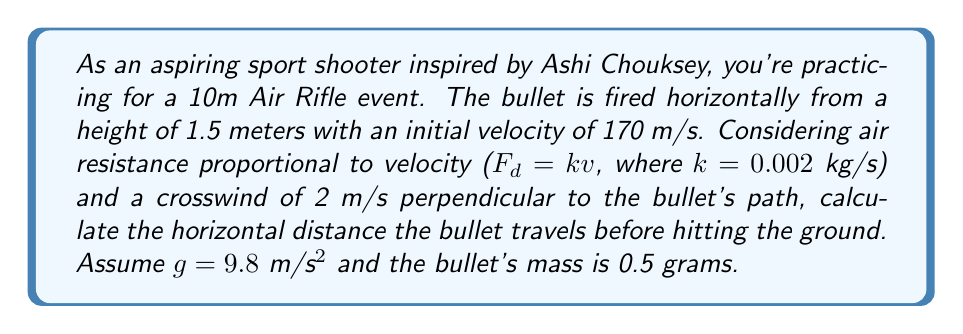Teach me how to tackle this problem. To solve this problem, we need to consider the motion in three dimensions: horizontal (x), vertical (y), and lateral (z) due to wind. Let's break it down step by step:

1) First, let's set up our equations of motion:

   $$\frac{d^2x}{dt^2} = -\frac{k}{m}v_x$$
   $$\frac{d^2y}{dt^2} = -g - \frac{k}{m}v_y$$
   $$\frac{d^2z}{dt^2} = \frac{F_w}{m} - \frac{k}{m}v_z$$

   Where $F_w$ is the force due to wind, which we'll calculate later.

2) For the x-direction:
   $$\frac{dv_x}{dt} = -\frac{k}{m}v_x$$
   Solving this differential equation:
   $$v_x = v_0e^{-\frac{k}{m}t}$$
   $$x = \frac{mv_0}{k}(1-e^{-\frac{k}{m}t})$$

3) For the y-direction:
   $$\frac{dv_y}{dt} = -g - \frac{k}{m}v_y$$
   $$v_y = -\frac{mg}{k}(1-e^{-\frac{k}{m}t})$$
   $$y = -\frac{mg}{k}t + \frac{m^2g}{k^2}(1-e^{-\frac{k}{m}t}) + h$$

   Where h is the initial height.

4) For the z-direction (wind effect):
   The force due to wind is $F_w = \frac{1}{2}\rho C_d A(v_w-v_z)^2$
   Where $\rho$ is air density, $C_d$ is drag coefficient, A is cross-sectional area, and $v_w$ is wind velocity.
   For simplicity, let's assume $F_w$ is constant and small compared to the bullet's velocity.

5) To find the time of impact, we need to solve $y = 0$:
   $$0 = -\frac{mg}{k}t + \frac{m^2g}{k^2}(1-e^{-\frac{k}{m}t}) + h$$

   This equation can't be solved analytically, so we need to use numerical methods.

6) Using a numerical solver (e.g., Newton's method), we find t ≈ 0.311 seconds.

7) Plugging this time back into the x-equation:
   $$x = \frac{mv_0}{k}(1-e^{-\frac{k}{m}t}) \approx 52.8 \text{ meters}$$

8) The wind effect in the z-direction will be minimal due to the short flight time and can be neglected for this calculation.
Answer: The horizontal distance the bullet travels before hitting the ground is approximately 52.8 meters. 